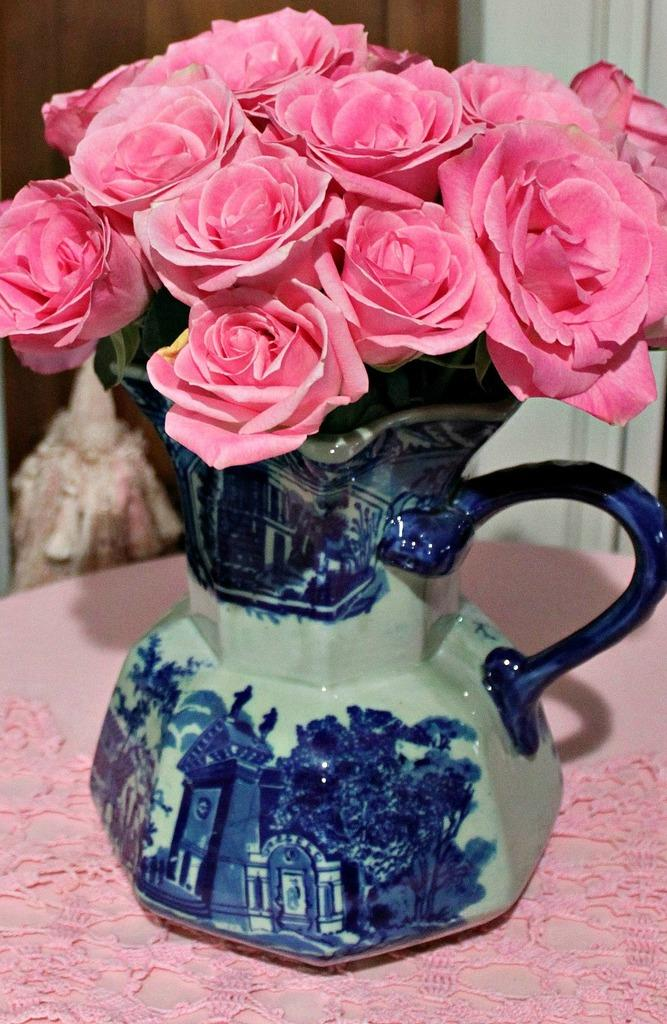What type of flowers are in the image? There are rose flowers in the image. Where are the rose flowers located? The rose flowers are in a flower pot. On what surface is the flower pot placed? The flower pot is placed on a table. What type of jam is being spread on the table in the image? There is no jam present in the image; it features rose flowers in a flower pot on a table. 